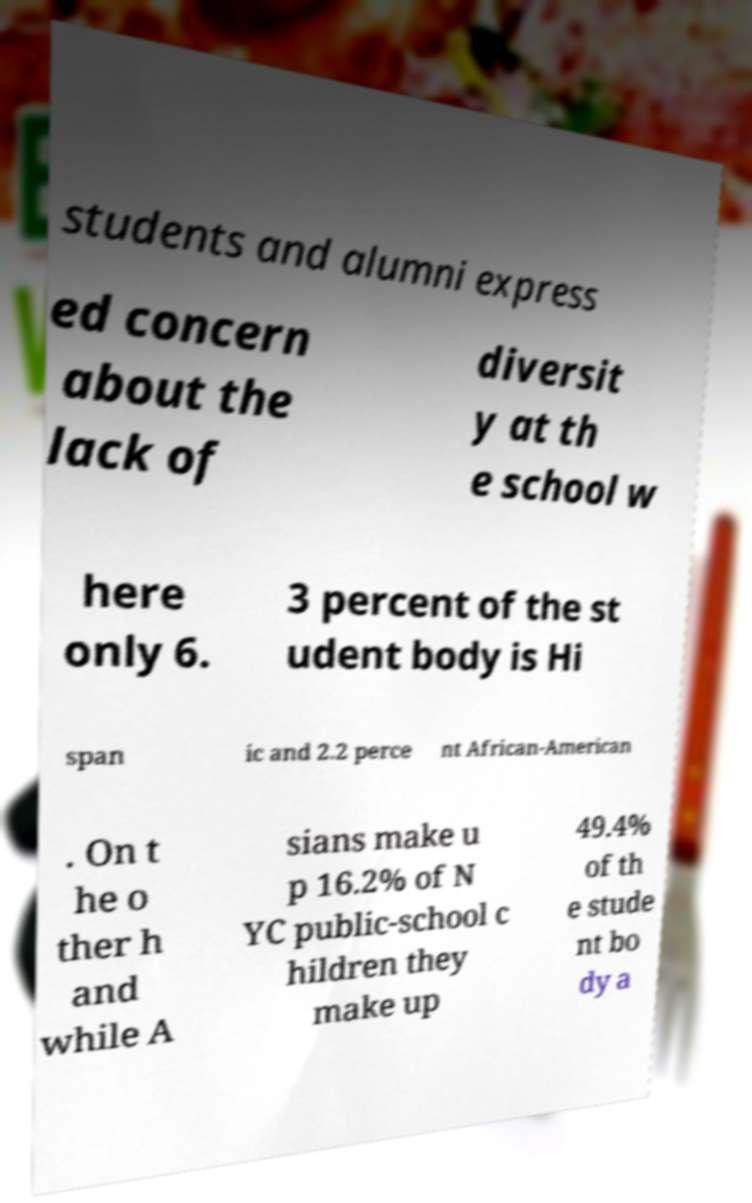Please read and relay the text visible in this image. What does it say? students and alumni express ed concern about the lack of diversit y at th e school w here only 6. 3 percent of the st udent body is Hi span ic and 2.2 perce nt African-American . On t he o ther h and while A sians make u p 16.2% of N YC public-school c hildren they make up 49.4% of th e stude nt bo dy a 